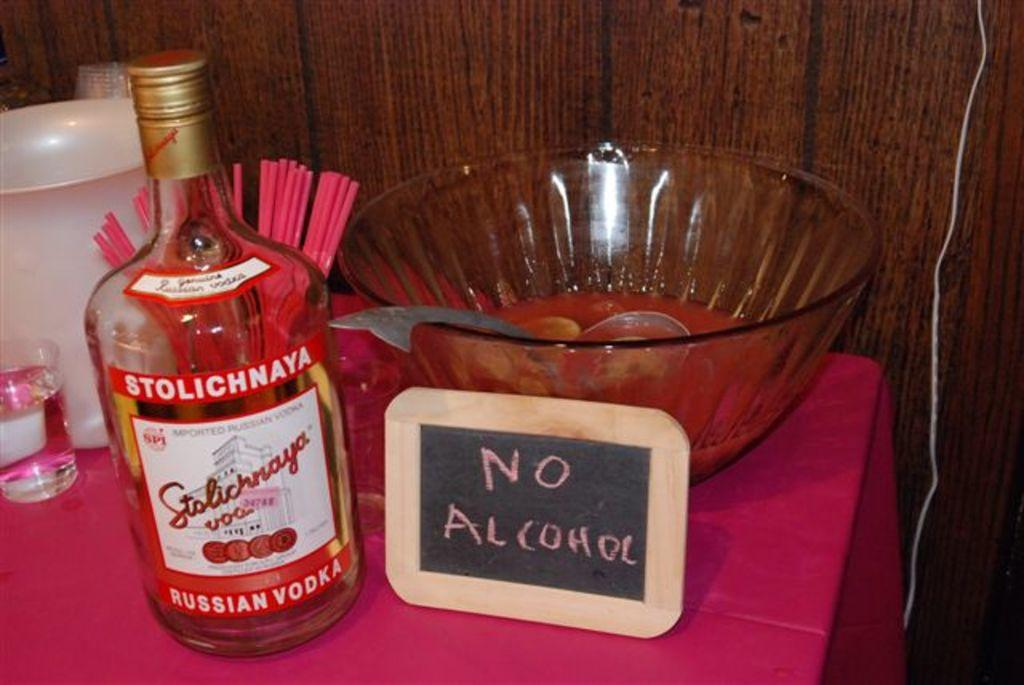What is the labeled item in the image? There is a bottle with a label in the image. What is the board used for in the image? The purpose of the board in the image is not specified, but it is present. What is in the bowl, and what utensil is placed with it? There is a bowl with a spoon in the image, but the contents are not specified. What is the glass used for in the image? The purpose of the glass in the image is not specified, but it is present. What is the jug used for in the image? The purpose of the jug in the image is not specified, but it is present. What are the straws used for in the image? The straws in the image are likely used for drinking, but their specific purpose is not specified. On what surface are the objects placed in the image? The objects are placed on a table in the image. What type of wall is visible in the background of the image? There is a wooden wall in the background of the image. Can you tell me how many times the objects in the image jump in the air? The objects in the image do not jump in the air; they are stationary on the table. What sense is being used by the objects in the image? Objects do not have senses; they are inanimate items. 